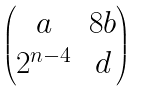Convert formula to latex. <formula><loc_0><loc_0><loc_500><loc_500>\begin{pmatrix} a & 8 b \\ 2 ^ { n - 4 } & d \end{pmatrix}</formula> 